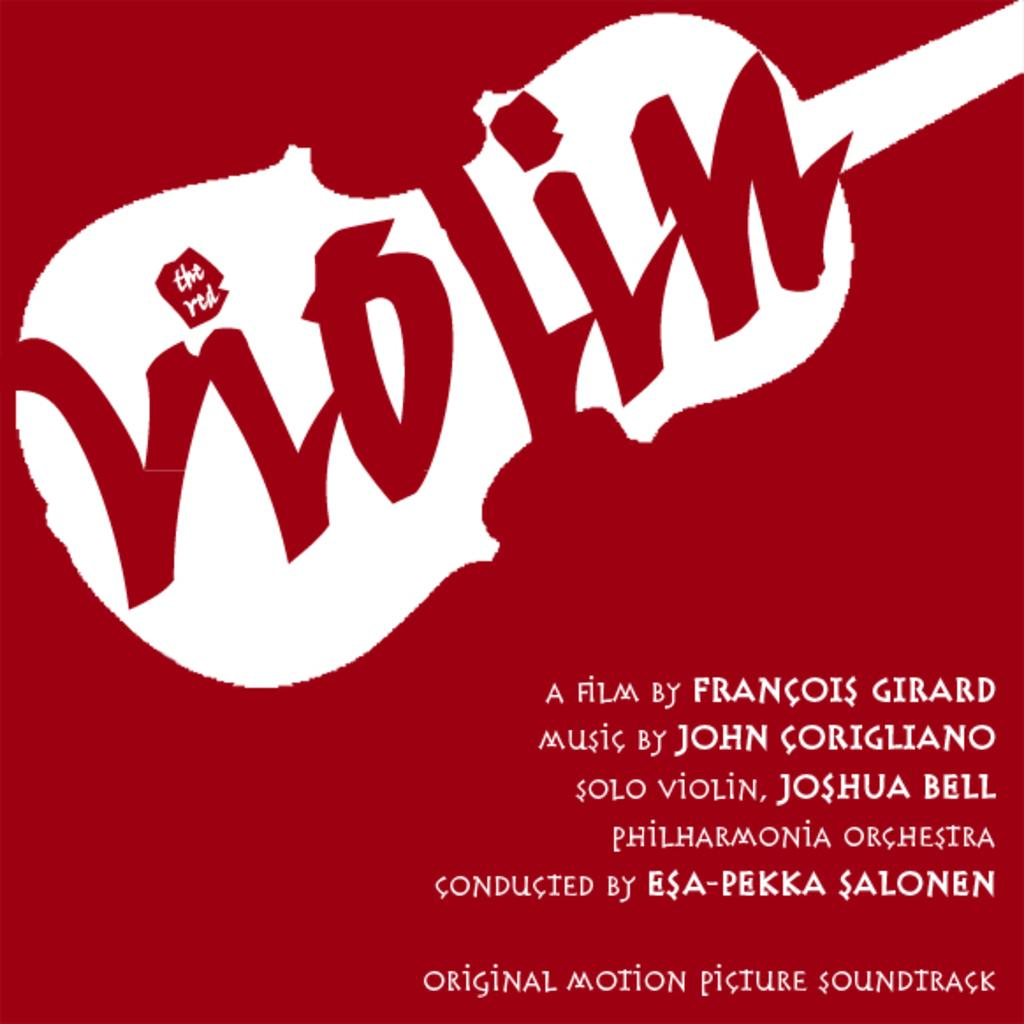<image>
Describe the image concisely. A promotional ad for a film titled the red violin. 